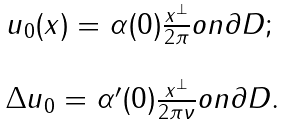Convert formula to latex. <formula><loc_0><loc_0><loc_500><loc_500>\begin{array} { l } u _ { 0 } ( x ) = \alpha ( 0 ) \frac { x ^ { \perp } } { 2 \pi } o n \partial D ; \\ \\ \Delta u _ { 0 } = \alpha ^ { \prime } ( 0 ) \frac { x ^ { \perp } } { 2 \pi \nu } o n \partial D . \end{array}</formula> 